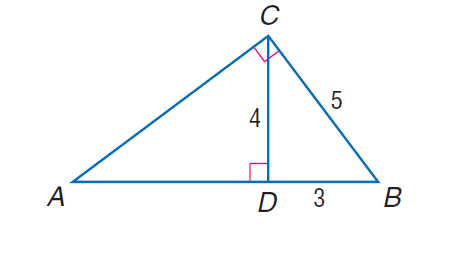Question: Find the perimeter of the given triangle. \triangle A B C, if \triangle A B C \sim \triangle C B D, C D = 4, D B = 3, and C B = 5.
Choices:
A. 15
B. 16
C. 18
D. 20
Answer with the letter. Answer: D 